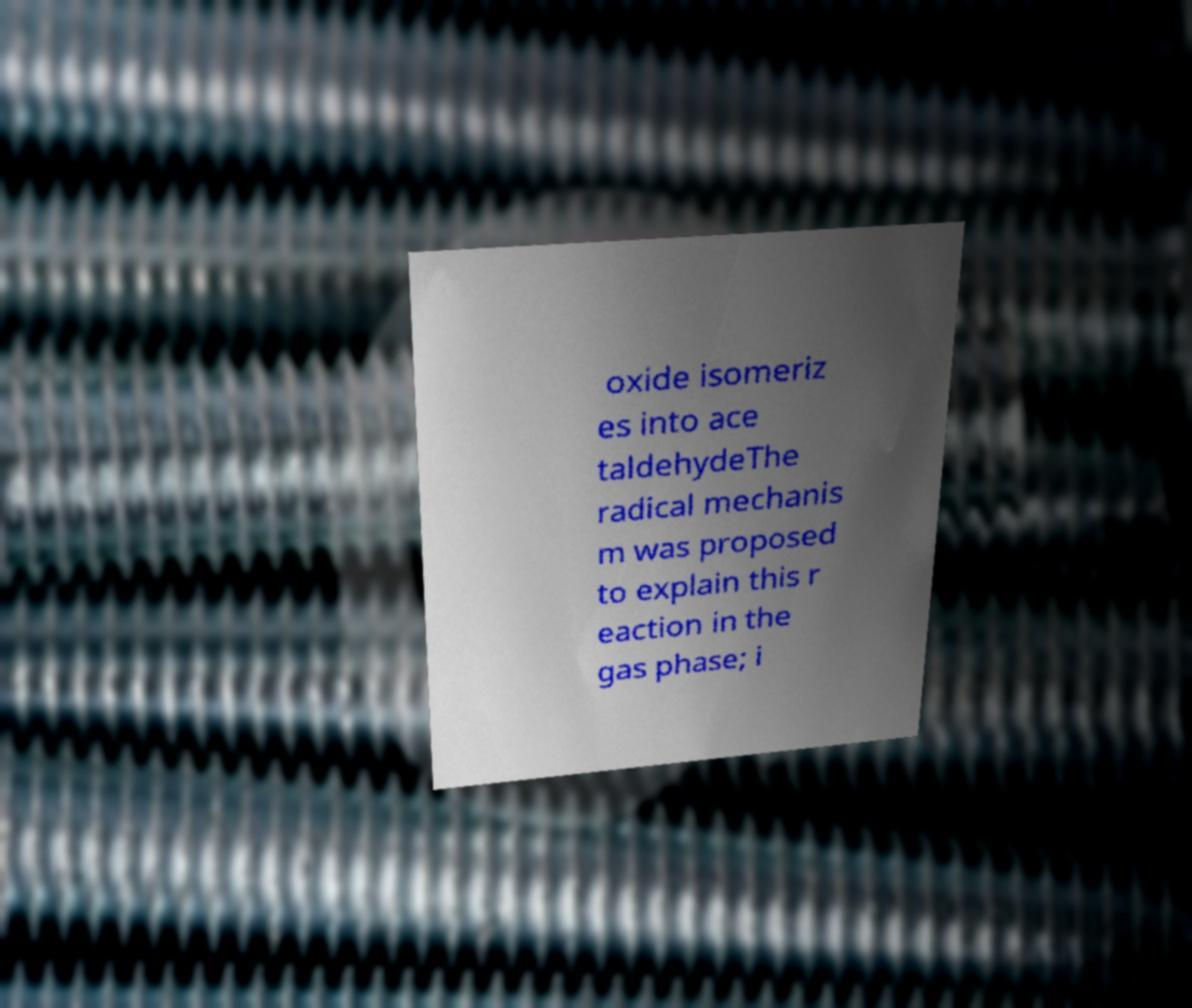Could you assist in decoding the text presented in this image and type it out clearly? oxide isomeriz es into ace taldehydeThe radical mechanis m was proposed to explain this r eaction in the gas phase; i 